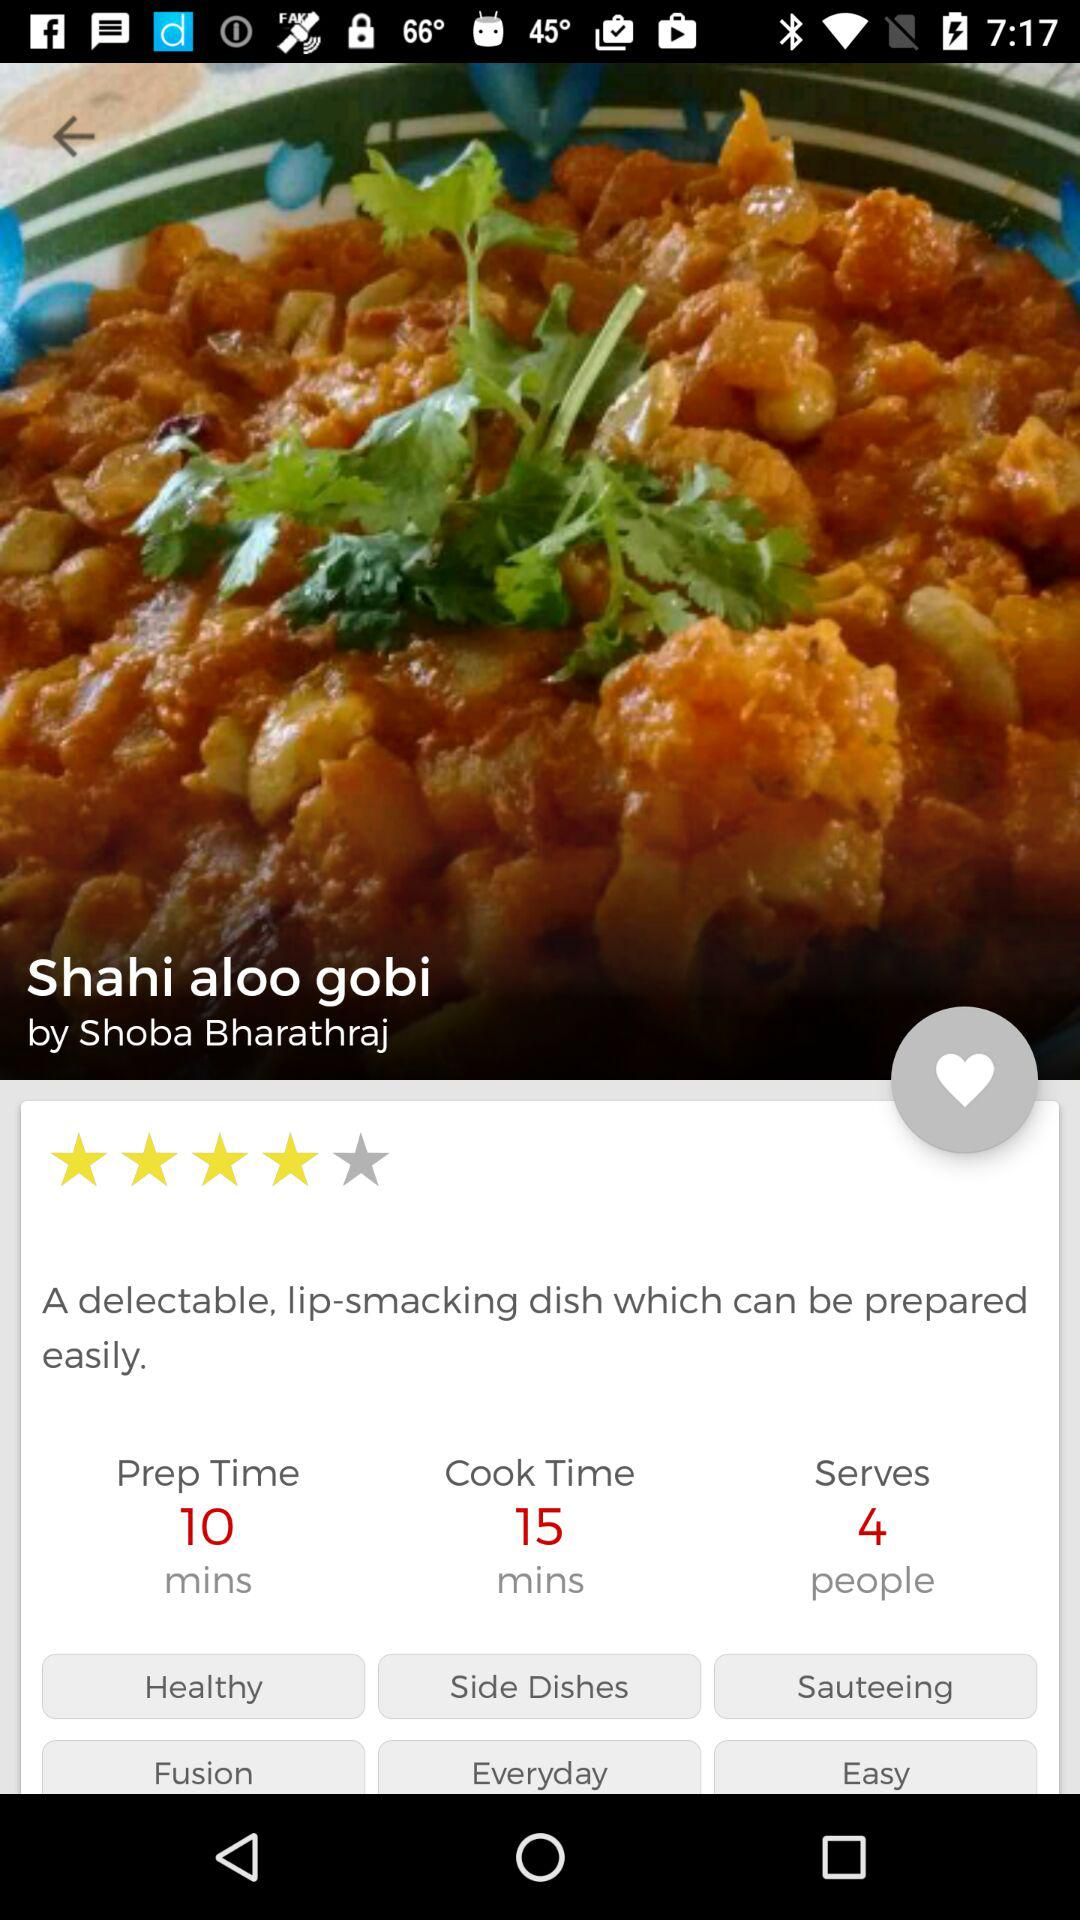Are onions required for the dish?
When the provided information is insufficient, respond with <no answer>. <no answer> 